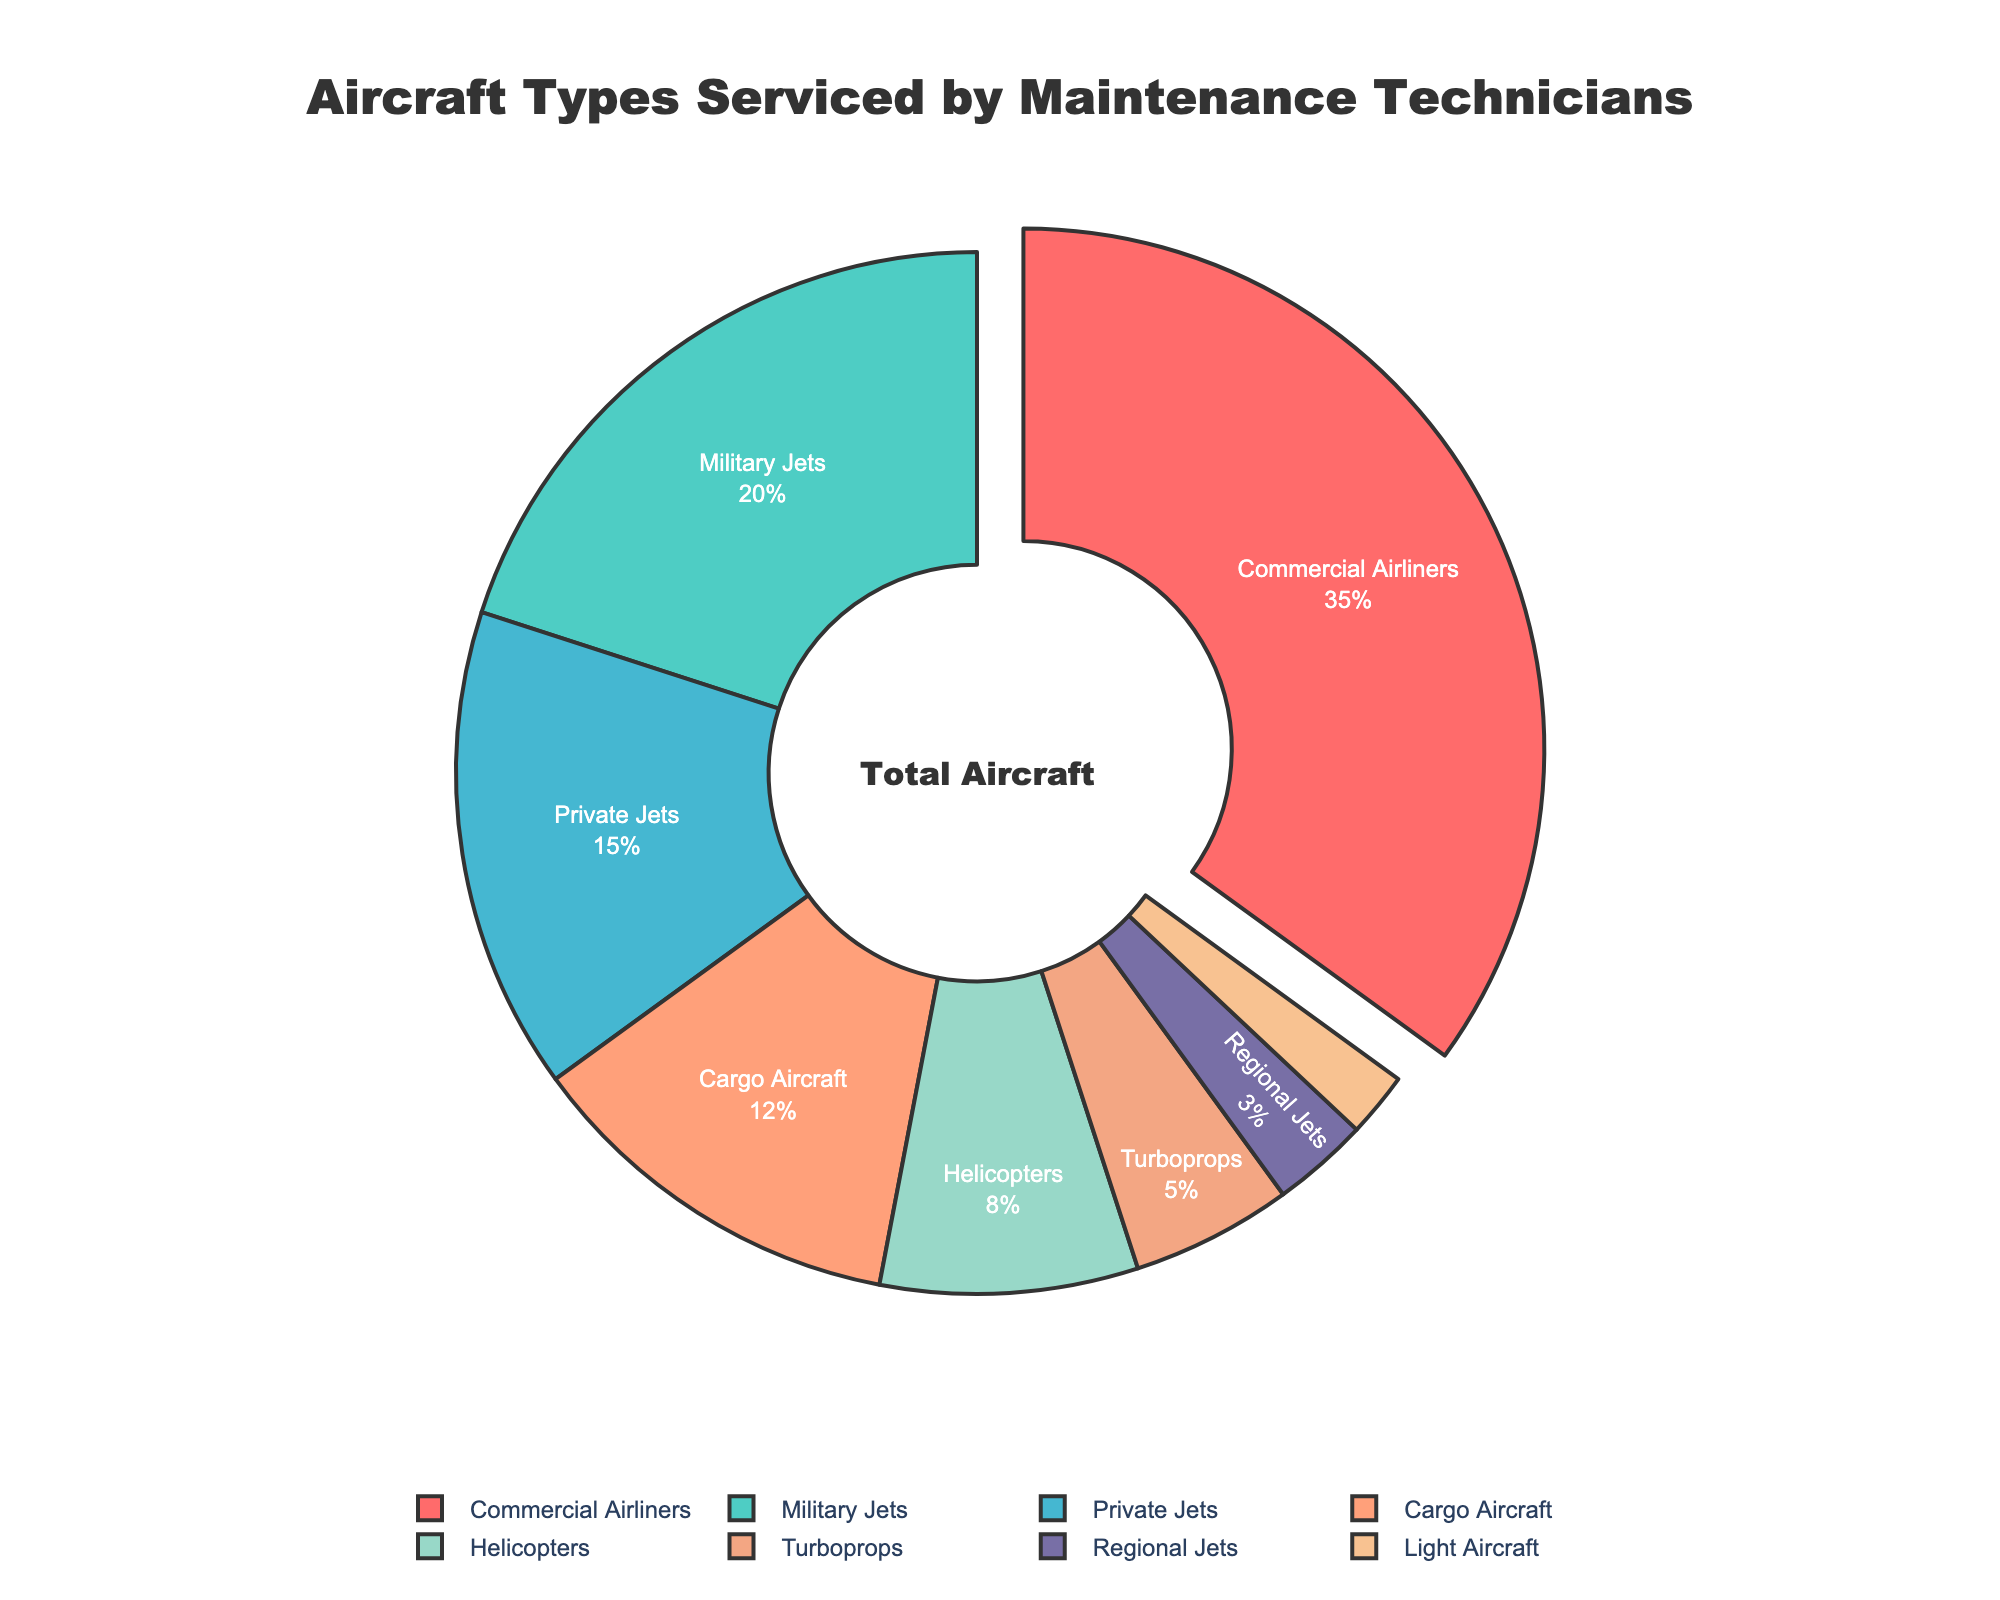What's the total percentage of aircraft types that are serviced less than Private Jets? The percentages of aircraft types less than Private Jets (15%) are Cargo Aircraft (12%), Helicopters (8%), Turboprops (5%), Regional Jets (3%), and Light Aircraft (2%). Summing these gives 12 + 8 + 5 + 3 + 2 = 30%.
Answer: 30% Which aircraft type has the highest percentage serviced by maintenance technicians? The color coding of the pie chart indicates that Commercial Airliners have a larger segment pulled out from the rest, indicating the highest percentage.
Answer: Commercial Airliners How much more percentage is serviced for Commercial Airliners compared to Military Jets? Commercial Airliners are 35%, and Military Jets are 20%. The difference is 35% - 20% = 15%.
Answer: 15% What’s the ratio of Cargo Aircraft to Regional Jets serviced? Cargo Aircraft are 12%, and Regional Jets are 3%. The ratio is 12% to 3%, which can be simplified to 4:1.
Answer: 4:1 Which aircraft types have smaller segments on the pie chart and combined make up less than 10%? The aircraft types with smaller segments labeled are Regional Jets (3%) and Light Aircraft (2%). Combined, these make 3% + 2% = 5%, which is less than 10%.
Answer: Regional Jets and Light Aircraft What’s the combined percentage for Private Jets, Cargo Aircraft, and Helicopters? The percentages are Private Jets (15%), Cargo Aircraft (12%), and Helicopters (8%). Summing these gives 15% + 12% + 8% = 35%.
Answer: 35% Which aircraft type has a percentage value that is closest to but less than Cargo Aircraft? Cargo Aircraft are 12%. The next closest percentage less than this is Helicopters at 8%.
Answer: Helicopters Do the combined percentages of Turboprops and Helicopters make up more or less than 15%? Turboprops are 5%, and Helicopters are 8%. Combined, they make 5% + 8% = 13%, which is less than 15%.
Answer: Less What’s the difference in percentage between the two largest aircraft types serviced? The two largest percentages are Commercial Airliners (35%) and Military Jets (20%). The difference is 35% - 20% = 15%.
Answer: 15% Which color represents the largest portion of aircraft serviced on the chart? The largest portion (35%) of the pie chart is pulled out and is red in color, indicating Commercial Airliners.
Answer: Red 